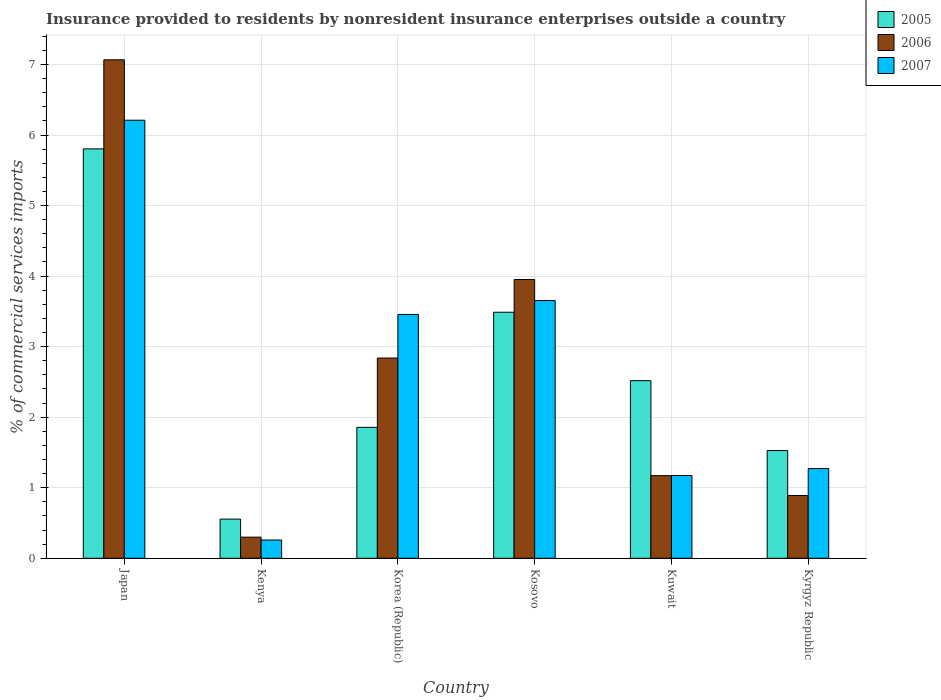How many different coloured bars are there?
Your answer should be compact. 3. How many groups of bars are there?
Your response must be concise. 6. Are the number of bars per tick equal to the number of legend labels?
Give a very brief answer. Yes. Are the number of bars on each tick of the X-axis equal?
Offer a terse response. Yes. What is the label of the 1st group of bars from the left?
Your answer should be compact. Japan. In how many cases, is the number of bars for a given country not equal to the number of legend labels?
Your answer should be very brief. 0. What is the Insurance provided to residents in 2006 in Kosovo?
Provide a short and direct response. 3.95. Across all countries, what is the maximum Insurance provided to residents in 2006?
Give a very brief answer. 7.07. Across all countries, what is the minimum Insurance provided to residents in 2006?
Give a very brief answer. 0.3. In which country was the Insurance provided to residents in 2007 maximum?
Your answer should be very brief. Japan. In which country was the Insurance provided to residents in 2005 minimum?
Your answer should be very brief. Kenya. What is the total Insurance provided to residents in 2006 in the graph?
Ensure brevity in your answer.  16.22. What is the difference between the Insurance provided to residents in 2006 in Kosovo and that in Kuwait?
Your answer should be compact. 2.78. What is the difference between the Insurance provided to residents in 2007 in Kuwait and the Insurance provided to residents in 2005 in Japan?
Provide a succinct answer. -4.63. What is the average Insurance provided to residents in 2006 per country?
Your answer should be compact. 2.7. What is the difference between the Insurance provided to residents of/in 2006 and Insurance provided to residents of/in 2007 in Kenya?
Give a very brief answer. 0.04. What is the ratio of the Insurance provided to residents in 2005 in Japan to that in Kyrgyz Republic?
Give a very brief answer. 3.8. Is the Insurance provided to residents in 2006 in Korea (Republic) less than that in Kuwait?
Give a very brief answer. No. What is the difference between the highest and the second highest Insurance provided to residents in 2007?
Keep it short and to the point. -0.2. What is the difference between the highest and the lowest Insurance provided to residents in 2007?
Your response must be concise. 5.95. What does the 2nd bar from the right in Kyrgyz Republic represents?
Ensure brevity in your answer.  2006. Is it the case that in every country, the sum of the Insurance provided to residents in 2006 and Insurance provided to residents in 2005 is greater than the Insurance provided to residents in 2007?
Your response must be concise. Yes. How many bars are there?
Your answer should be very brief. 18. Are all the bars in the graph horizontal?
Your answer should be compact. No. How many countries are there in the graph?
Give a very brief answer. 6. Are the values on the major ticks of Y-axis written in scientific E-notation?
Your response must be concise. No. How many legend labels are there?
Your answer should be very brief. 3. What is the title of the graph?
Give a very brief answer. Insurance provided to residents by nonresident insurance enterprises outside a country. What is the label or title of the X-axis?
Provide a short and direct response. Country. What is the label or title of the Y-axis?
Your answer should be very brief. % of commercial services imports. What is the % of commercial services imports of 2005 in Japan?
Your response must be concise. 5.8. What is the % of commercial services imports of 2006 in Japan?
Offer a terse response. 7.07. What is the % of commercial services imports of 2007 in Japan?
Offer a very short reply. 6.21. What is the % of commercial services imports in 2005 in Kenya?
Provide a succinct answer. 0.56. What is the % of commercial services imports in 2006 in Kenya?
Provide a short and direct response. 0.3. What is the % of commercial services imports in 2007 in Kenya?
Ensure brevity in your answer.  0.26. What is the % of commercial services imports of 2005 in Korea (Republic)?
Make the answer very short. 1.86. What is the % of commercial services imports in 2006 in Korea (Republic)?
Give a very brief answer. 2.84. What is the % of commercial services imports in 2007 in Korea (Republic)?
Your response must be concise. 3.46. What is the % of commercial services imports in 2005 in Kosovo?
Give a very brief answer. 3.49. What is the % of commercial services imports in 2006 in Kosovo?
Ensure brevity in your answer.  3.95. What is the % of commercial services imports in 2007 in Kosovo?
Your answer should be compact. 3.65. What is the % of commercial services imports in 2005 in Kuwait?
Your response must be concise. 2.52. What is the % of commercial services imports in 2006 in Kuwait?
Give a very brief answer. 1.17. What is the % of commercial services imports of 2007 in Kuwait?
Your answer should be compact. 1.17. What is the % of commercial services imports in 2005 in Kyrgyz Republic?
Give a very brief answer. 1.53. What is the % of commercial services imports in 2006 in Kyrgyz Republic?
Keep it short and to the point. 0.89. What is the % of commercial services imports in 2007 in Kyrgyz Republic?
Keep it short and to the point. 1.27. Across all countries, what is the maximum % of commercial services imports of 2005?
Provide a short and direct response. 5.8. Across all countries, what is the maximum % of commercial services imports in 2006?
Offer a very short reply. 7.07. Across all countries, what is the maximum % of commercial services imports in 2007?
Your answer should be compact. 6.21. Across all countries, what is the minimum % of commercial services imports in 2005?
Make the answer very short. 0.56. Across all countries, what is the minimum % of commercial services imports of 2006?
Ensure brevity in your answer.  0.3. Across all countries, what is the minimum % of commercial services imports in 2007?
Your response must be concise. 0.26. What is the total % of commercial services imports of 2005 in the graph?
Your answer should be very brief. 15.75. What is the total % of commercial services imports of 2006 in the graph?
Offer a very short reply. 16.22. What is the total % of commercial services imports of 2007 in the graph?
Your answer should be very brief. 16.02. What is the difference between the % of commercial services imports in 2005 in Japan and that in Kenya?
Your answer should be compact. 5.25. What is the difference between the % of commercial services imports of 2006 in Japan and that in Kenya?
Make the answer very short. 6.77. What is the difference between the % of commercial services imports in 2007 in Japan and that in Kenya?
Ensure brevity in your answer.  5.95. What is the difference between the % of commercial services imports in 2005 in Japan and that in Korea (Republic)?
Your response must be concise. 3.95. What is the difference between the % of commercial services imports in 2006 in Japan and that in Korea (Republic)?
Give a very brief answer. 4.23. What is the difference between the % of commercial services imports in 2007 in Japan and that in Korea (Republic)?
Ensure brevity in your answer.  2.75. What is the difference between the % of commercial services imports in 2005 in Japan and that in Kosovo?
Give a very brief answer. 2.32. What is the difference between the % of commercial services imports of 2006 in Japan and that in Kosovo?
Your response must be concise. 3.11. What is the difference between the % of commercial services imports of 2007 in Japan and that in Kosovo?
Your answer should be compact. 2.56. What is the difference between the % of commercial services imports of 2005 in Japan and that in Kuwait?
Your response must be concise. 3.29. What is the difference between the % of commercial services imports in 2006 in Japan and that in Kuwait?
Keep it short and to the point. 5.89. What is the difference between the % of commercial services imports in 2007 in Japan and that in Kuwait?
Provide a succinct answer. 5.04. What is the difference between the % of commercial services imports in 2005 in Japan and that in Kyrgyz Republic?
Ensure brevity in your answer.  4.28. What is the difference between the % of commercial services imports of 2006 in Japan and that in Kyrgyz Republic?
Keep it short and to the point. 6.18. What is the difference between the % of commercial services imports in 2007 in Japan and that in Kyrgyz Republic?
Your answer should be very brief. 4.94. What is the difference between the % of commercial services imports in 2005 in Kenya and that in Korea (Republic)?
Your answer should be compact. -1.3. What is the difference between the % of commercial services imports of 2006 in Kenya and that in Korea (Republic)?
Ensure brevity in your answer.  -2.54. What is the difference between the % of commercial services imports in 2007 in Kenya and that in Korea (Republic)?
Your response must be concise. -3.2. What is the difference between the % of commercial services imports in 2005 in Kenya and that in Kosovo?
Ensure brevity in your answer.  -2.93. What is the difference between the % of commercial services imports of 2006 in Kenya and that in Kosovo?
Provide a short and direct response. -3.65. What is the difference between the % of commercial services imports in 2007 in Kenya and that in Kosovo?
Your answer should be very brief. -3.39. What is the difference between the % of commercial services imports of 2005 in Kenya and that in Kuwait?
Ensure brevity in your answer.  -1.96. What is the difference between the % of commercial services imports in 2006 in Kenya and that in Kuwait?
Your response must be concise. -0.87. What is the difference between the % of commercial services imports of 2007 in Kenya and that in Kuwait?
Keep it short and to the point. -0.91. What is the difference between the % of commercial services imports in 2005 in Kenya and that in Kyrgyz Republic?
Your answer should be compact. -0.97. What is the difference between the % of commercial services imports in 2006 in Kenya and that in Kyrgyz Republic?
Offer a very short reply. -0.59. What is the difference between the % of commercial services imports in 2007 in Kenya and that in Kyrgyz Republic?
Make the answer very short. -1.01. What is the difference between the % of commercial services imports in 2005 in Korea (Republic) and that in Kosovo?
Give a very brief answer. -1.63. What is the difference between the % of commercial services imports in 2006 in Korea (Republic) and that in Kosovo?
Make the answer very short. -1.11. What is the difference between the % of commercial services imports of 2007 in Korea (Republic) and that in Kosovo?
Provide a short and direct response. -0.2. What is the difference between the % of commercial services imports of 2005 in Korea (Republic) and that in Kuwait?
Keep it short and to the point. -0.66. What is the difference between the % of commercial services imports of 2006 in Korea (Republic) and that in Kuwait?
Keep it short and to the point. 1.67. What is the difference between the % of commercial services imports in 2007 in Korea (Republic) and that in Kuwait?
Offer a terse response. 2.28. What is the difference between the % of commercial services imports in 2005 in Korea (Republic) and that in Kyrgyz Republic?
Your answer should be very brief. 0.33. What is the difference between the % of commercial services imports in 2006 in Korea (Republic) and that in Kyrgyz Republic?
Provide a short and direct response. 1.95. What is the difference between the % of commercial services imports of 2007 in Korea (Republic) and that in Kyrgyz Republic?
Give a very brief answer. 2.19. What is the difference between the % of commercial services imports of 2005 in Kosovo and that in Kuwait?
Offer a terse response. 0.97. What is the difference between the % of commercial services imports in 2006 in Kosovo and that in Kuwait?
Your answer should be compact. 2.78. What is the difference between the % of commercial services imports of 2007 in Kosovo and that in Kuwait?
Offer a terse response. 2.48. What is the difference between the % of commercial services imports of 2005 in Kosovo and that in Kyrgyz Republic?
Your answer should be compact. 1.96. What is the difference between the % of commercial services imports of 2006 in Kosovo and that in Kyrgyz Republic?
Your answer should be very brief. 3.06. What is the difference between the % of commercial services imports of 2007 in Kosovo and that in Kyrgyz Republic?
Give a very brief answer. 2.38. What is the difference between the % of commercial services imports in 2005 in Kuwait and that in Kyrgyz Republic?
Provide a short and direct response. 0.99. What is the difference between the % of commercial services imports in 2006 in Kuwait and that in Kyrgyz Republic?
Provide a succinct answer. 0.28. What is the difference between the % of commercial services imports in 2007 in Kuwait and that in Kyrgyz Republic?
Offer a very short reply. -0.1. What is the difference between the % of commercial services imports of 2005 in Japan and the % of commercial services imports of 2006 in Kenya?
Offer a terse response. 5.5. What is the difference between the % of commercial services imports in 2005 in Japan and the % of commercial services imports in 2007 in Kenya?
Your response must be concise. 5.54. What is the difference between the % of commercial services imports in 2006 in Japan and the % of commercial services imports in 2007 in Kenya?
Your answer should be very brief. 6.81. What is the difference between the % of commercial services imports of 2005 in Japan and the % of commercial services imports of 2006 in Korea (Republic)?
Your answer should be very brief. 2.96. What is the difference between the % of commercial services imports of 2005 in Japan and the % of commercial services imports of 2007 in Korea (Republic)?
Make the answer very short. 2.35. What is the difference between the % of commercial services imports of 2006 in Japan and the % of commercial services imports of 2007 in Korea (Republic)?
Your response must be concise. 3.61. What is the difference between the % of commercial services imports in 2005 in Japan and the % of commercial services imports in 2006 in Kosovo?
Your answer should be compact. 1.85. What is the difference between the % of commercial services imports in 2005 in Japan and the % of commercial services imports in 2007 in Kosovo?
Make the answer very short. 2.15. What is the difference between the % of commercial services imports in 2006 in Japan and the % of commercial services imports in 2007 in Kosovo?
Your answer should be very brief. 3.41. What is the difference between the % of commercial services imports of 2005 in Japan and the % of commercial services imports of 2006 in Kuwait?
Provide a short and direct response. 4.63. What is the difference between the % of commercial services imports in 2005 in Japan and the % of commercial services imports in 2007 in Kuwait?
Provide a succinct answer. 4.63. What is the difference between the % of commercial services imports in 2006 in Japan and the % of commercial services imports in 2007 in Kuwait?
Your answer should be compact. 5.89. What is the difference between the % of commercial services imports of 2005 in Japan and the % of commercial services imports of 2006 in Kyrgyz Republic?
Ensure brevity in your answer.  4.91. What is the difference between the % of commercial services imports of 2005 in Japan and the % of commercial services imports of 2007 in Kyrgyz Republic?
Provide a succinct answer. 4.53. What is the difference between the % of commercial services imports of 2006 in Japan and the % of commercial services imports of 2007 in Kyrgyz Republic?
Offer a very short reply. 5.79. What is the difference between the % of commercial services imports of 2005 in Kenya and the % of commercial services imports of 2006 in Korea (Republic)?
Provide a short and direct response. -2.28. What is the difference between the % of commercial services imports of 2005 in Kenya and the % of commercial services imports of 2007 in Korea (Republic)?
Your response must be concise. -2.9. What is the difference between the % of commercial services imports of 2006 in Kenya and the % of commercial services imports of 2007 in Korea (Republic)?
Offer a terse response. -3.16. What is the difference between the % of commercial services imports of 2005 in Kenya and the % of commercial services imports of 2006 in Kosovo?
Your response must be concise. -3.4. What is the difference between the % of commercial services imports of 2005 in Kenya and the % of commercial services imports of 2007 in Kosovo?
Your answer should be very brief. -3.1. What is the difference between the % of commercial services imports of 2006 in Kenya and the % of commercial services imports of 2007 in Kosovo?
Offer a very short reply. -3.35. What is the difference between the % of commercial services imports in 2005 in Kenya and the % of commercial services imports in 2006 in Kuwait?
Give a very brief answer. -0.62. What is the difference between the % of commercial services imports of 2005 in Kenya and the % of commercial services imports of 2007 in Kuwait?
Make the answer very short. -0.62. What is the difference between the % of commercial services imports in 2006 in Kenya and the % of commercial services imports in 2007 in Kuwait?
Give a very brief answer. -0.87. What is the difference between the % of commercial services imports in 2005 in Kenya and the % of commercial services imports in 2006 in Kyrgyz Republic?
Give a very brief answer. -0.33. What is the difference between the % of commercial services imports in 2005 in Kenya and the % of commercial services imports in 2007 in Kyrgyz Republic?
Give a very brief answer. -0.72. What is the difference between the % of commercial services imports of 2006 in Kenya and the % of commercial services imports of 2007 in Kyrgyz Republic?
Make the answer very short. -0.97. What is the difference between the % of commercial services imports of 2005 in Korea (Republic) and the % of commercial services imports of 2006 in Kosovo?
Make the answer very short. -2.1. What is the difference between the % of commercial services imports of 2005 in Korea (Republic) and the % of commercial services imports of 2007 in Kosovo?
Provide a succinct answer. -1.8. What is the difference between the % of commercial services imports of 2006 in Korea (Republic) and the % of commercial services imports of 2007 in Kosovo?
Ensure brevity in your answer.  -0.81. What is the difference between the % of commercial services imports in 2005 in Korea (Republic) and the % of commercial services imports in 2006 in Kuwait?
Give a very brief answer. 0.68. What is the difference between the % of commercial services imports in 2005 in Korea (Republic) and the % of commercial services imports in 2007 in Kuwait?
Provide a succinct answer. 0.68. What is the difference between the % of commercial services imports of 2006 in Korea (Republic) and the % of commercial services imports of 2007 in Kuwait?
Your answer should be compact. 1.67. What is the difference between the % of commercial services imports in 2005 in Korea (Republic) and the % of commercial services imports in 2006 in Kyrgyz Republic?
Offer a terse response. 0.97. What is the difference between the % of commercial services imports of 2005 in Korea (Republic) and the % of commercial services imports of 2007 in Kyrgyz Republic?
Provide a succinct answer. 0.58. What is the difference between the % of commercial services imports of 2006 in Korea (Republic) and the % of commercial services imports of 2007 in Kyrgyz Republic?
Ensure brevity in your answer.  1.57. What is the difference between the % of commercial services imports of 2005 in Kosovo and the % of commercial services imports of 2006 in Kuwait?
Your answer should be very brief. 2.32. What is the difference between the % of commercial services imports in 2005 in Kosovo and the % of commercial services imports in 2007 in Kuwait?
Ensure brevity in your answer.  2.31. What is the difference between the % of commercial services imports of 2006 in Kosovo and the % of commercial services imports of 2007 in Kuwait?
Provide a short and direct response. 2.78. What is the difference between the % of commercial services imports of 2005 in Kosovo and the % of commercial services imports of 2006 in Kyrgyz Republic?
Provide a short and direct response. 2.6. What is the difference between the % of commercial services imports in 2005 in Kosovo and the % of commercial services imports in 2007 in Kyrgyz Republic?
Your response must be concise. 2.22. What is the difference between the % of commercial services imports in 2006 in Kosovo and the % of commercial services imports in 2007 in Kyrgyz Republic?
Provide a succinct answer. 2.68. What is the difference between the % of commercial services imports of 2005 in Kuwait and the % of commercial services imports of 2006 in Kyrgyz Republic?
Provide a succinct answer. 1.63. What is the difference between the % of commercial services imports in 2005 in Kuwait and the % of commercial services imports in 2007 in Kyrgyz Republic?
Provide a succinct answer. 1.25. What is the difference between the % of commercial services imports of 2006 in Kuwait and the % of commercial services imports of 2007 in Kyrgyz Republic?
Ensure brevity in your answer.  -0.1. What is the average % of commercial services imports in 2005 per country?
Give a very brief answer. 2.62. What is the average % of commercial services imports of 2006 per country?
Offer a very short reply. 2.7. What is the average % of commercial services imports in 2007 per country?
Provide a short and direct response. 2.67. What is the difference between the % of commercial services imports of 2005 and % of commercial services imports of 2006 in Japan?
Provide a short and direct response. -1.26. What is the difference between the % of commercial services imports of 2005 and % of commercial services imports of 2007 in Japan?
Ensure brevity in your answer.  -0.41. What is the difference between the % of commercial services imports of 2006 and % of commercial services imports of 2007 in Japan?
Make the answer very short. 0.86. What is the difference between the % of commercial services imports in 2005 and % of commercial services imports in 2006 in Kenya?
Provide a succinct answer. 0.26. What is the difference between the % of commercial services imports of 2005 and % of commercial services imports of 2007 in Kenya?
Keep it short and to the point. 0.3. What is the difference between the % of commercial services imports of 2006 and % of commercial services imports of 2007 in Kenya?
Give a very brief answer. 0.04. What is the difference between the % of commercial services imports in 2005 and % of commercial services imports in 2006 in Korea (Republic)?
Provide a succinct answer. -0.98. What is the difference between the % of commercial services imports of 2005 and % of commercial services imports of 2007 in Korea (Republic)?
Offer a very short reply. -1.6. What is the difference between the % of commercial services imports in 2006 and % of commercial services imports in 2007 in Korea (Republic)?
Provide a short and direct response. -0.62. What is the difference between the % of commercial services imports of 2005 and % of commercial services imports of 2006 in Kosovo?
Your answer should be very brief. -0.46. What is the difference between the % of commercial services imports in 2005 and % of commercial services imports in 2007 in Kosovo?
Give a very brief answer. -0.17. What is the difference between the % of commercial services imports in 2006 and % of commercial services imports in 2007 in Kosovo?
Your answer should be very brief. 0.3. What is the difference between the % of commercial services imports of 2005 and % of commercial services imports of 2006 in Kuwait?
Your answer should be compact. 1.35. What is the difference between the % of commercial services imports in 2005 and % of commercial services imports in 2007 in Kuwait?
Keep it short and to the point. 1.34. What is the difference between the % of commercial services imports in 2006 and % of commercial services imports in 2007 in Kuwait?
Make the answer very short. -0. What is the difference between the % of commercial services imports of 2005 and % of commercial services imports of 2006 in Kyrgyz Republic?
Make the answer very short. 0.64. What is the difference between the % of commercial services imports of 2005 and % of commercial services imports of 2007 in Kyrgyz Republic?
Ensure brevity in your answer.  0.26. What is the difference between the % of commercial services imports in 2006 and % of commercial services imports in 2007 in Kyrgyz Republic?
Keep it short and to the point. -0.38. What is the ratio of the % of commercial services imports in 2005 in Japan to that in Kenya?
Give a very brief answer. 10.45. What is the ratio of the % of commercial services imports of 2006 in Japan to that in Kenya?
Give a very brief answer. 23.59. What is the ratio of the % of commercial services imports of 2007 in Japan to that in Kenya?
Your answer should be compact. 24.01. What is the ratio of the % of commercial services imports of 2005 in Japan to that in Korea (Republic)?
Give a very brief answer. 3.13. What is the ratio of the % of commercial services imports of 2006 in Japan to that in Korea (Republic)?
Ensure brevity in your answer.  2.49. What is the ratio of the % of commercial services imports in 2007 in Japan to that in Korea (Republic)?
Provide a succinct answer. 1.8. What is the ratio of the % of commercial services imports of 2005 in Japan to that in Kosovo?
Make the answer very short. 1.66. What is the ratio of the % of commercial services imports in 2006 in Japan to that in Kosovo?
Give a very brief answer. 1.79. What is the ratio of the % of commercial services imports of 2007 in Japan to that in Kosovo?
Give a very brief answer. 1.7. What is the ratio of the % of commercial services imports of 2005 in Japan to that in Kuwait?
Keep it short and to the point. 2.31. What is the ratio of the % of commercial services imports in 2006 in Japan to that in Kuwait?
Make the answer very short. 6.03. What is the ratio of the % of commercial services imports of 2007 in Japan to that in Kuwait?
Ensure brevity in your answer.  5.29. What is the ratio of the % of commercial services imports in 2005 in Japan to that in Kyrgyz Republic?
Your answer should be compact. 3.8. What is the ratio of the % of commercial services imports in 2006 in Japan to that in Kyrgyz Republic?
Offer a terse response. 7.94. What is the ratio of the % of commercial services imports of 2007 in Japan to that in Kyrgyz Republic?
Give a very brief answer. 4.88. What is the ratio of the % of commercial services imports of 2005 in Kenya to that in Korea (Republic)?
Keep it short and to the point. 0.3. What is the ratio of the % of commercial services imports in 2006 in Kenya to that in Korea (Republic)?
Make the answer very short. 0.11. What is the ratio of the % of commercial services imports in 2007 in Kenya to that in Korea (Republic)?
Give a very brief answer. 0.07. What is the ratio of the % of commercial services imports of 2005 in Kenya to that in Kosovo?
Ensure brevity in your answer.  0.16. What is the ratio of the % of commercial services imports in 2006 in Kenya to that in Kosovo?
Your answer should be compact. 0.08. What is the ratio of the % of commercial services imports of 2007 in Kenya to that in Kosovo?
Offer a terse response. 0.07. What is the ratio of the % of commercial services imports of 2005 in Kenya to that in Kuwait?
Your answer should be compact. 0.22. What is the ratio of the % of commercial services imports in 2006 in Kenya to that in Kuwait?
Offer a terse response. 0.26. What is the ratio of the % of commercial services imports of 2007 in Kenya to that in Kuwait?
Your answer should be very brief. 0.22. What is the ratio of the % of commercial services imports in 2005 in Kenya to that in Kyrgyz Republic?
Make the answer very short. 0.36. What is the ratio of the % of commercial services imports of 2006 in Kenya to that in Kyrgyz Republic?
Ensure brevity in your answer.  0.34. What is the ratio of the % of commercial services imports of 2007 in Kenya to that in Kyrgyz Republic?
Keep it short and to the point. 0.2. What is the ratio of the % of commercial services imports in 2005 in Korea (Republic) to that in Kosovo?
Offer a very short reply. 0.53. What is the ratio of the % of commercial services imports of 2006 in Korea (Republic) to that in Kosovo?
Your response must be concise. 0.72. What is the ratio of the % of commercial services imports in 2007 in Korea (Republic) to that in Kosovo?
Provide a succinct answer. 0.95. What is the ratio of the % of commercial services imports in 2005 in Korea (Republic) to that in Kuwait?
Offer a terse response. 0.74. What is the ratio of the % of commercial services imports of 2006 in Korea (Republic) to that in Kuwait?
Give a very brief answer. 2.42. What is the ratio of the % of commercial services imports in 2007 in Korea (Republic) to that in Kuwait?
Your answer should be very brief. 2.95. What is the ratio of the % of commercial services imports in 2005 in Korea (Republic) to that in Kyrgyz Republic?
Keep it short and to the point. 1.22. What is the ratio of the % of commercial services imports of 2006 in Korea (Republic) to that in Kyrgyz Republic?
Ensure brevity in your answer.  3.19. What is the ratio of the % of commercial services imports of 2007 in Korea (Republic) to that in Kyrgyz Republic?
Your answer should be very brief. 2.72. What is the ratio of the % of commercial services imports of 2005 in Kosovo to that in Kuwait?
Your answer should be compact. 1.39. What is the ratio of the % of commercial services imports of 2006 in Kosovo to that in Kuwait?
Provide a succinct answer. 3.37. What is the ratio of the % of commercial services imports in 2007 in Kosovo to that in Kuwait?
Ensure brevity in your answer.  3.11. What is the ratio of the % of commercial services imports of 2005 in Kosovo to that in Kyrgyz Republic?
Your answer should be compact. 2.28. What is the ratio of the % of commercial services imports of 2006 in Kosovo to that in Kyrgyz Republic?
Offer a very short reply. 4.44. What is the ratio of the % of commercial services imports of 2007 in Kosovo to that in Kyrgyz Republic?
Your answer should be compact. 2.87. What is the ratio of the % of commercial services imports in 2005 in Kuwait to that in Kyrgyz Republic?
Make the answer very short. 1.65. What is the ratio of the % of commercial services imports in 2006 in Kuwait to that in Kyrgyz Republic?
Your answer should be very brief. 1.32. What is the ratio of the % of commercial services imports of 2007 in Kuwait to that in Kyrgyz Republic?
Make the answer very short. 0.92. What is the difference between the highest and the second highest % of commercial services imports of 2005?
Offer a terse response. 2.32. What is the difference between the highest and the second highest % of commercial services imports in 2006?
Offer a terse response. 3.11. What is the difference between the highest and the second highest % of commercial services imports in 2007?
Give a very brief answer. 2.56. What is the difference between the highest and the lowest % of commercial services imports of 2005?
Keep it short and to the point. 5.25. What is the difference between the highest and the lowest % of commercial services imports in 2006?
Provide a succinct answer. 6.77. What is the difference between the highest and the lowest % of commercial services imports of 2007?
Make the answer very short. 5.95. 